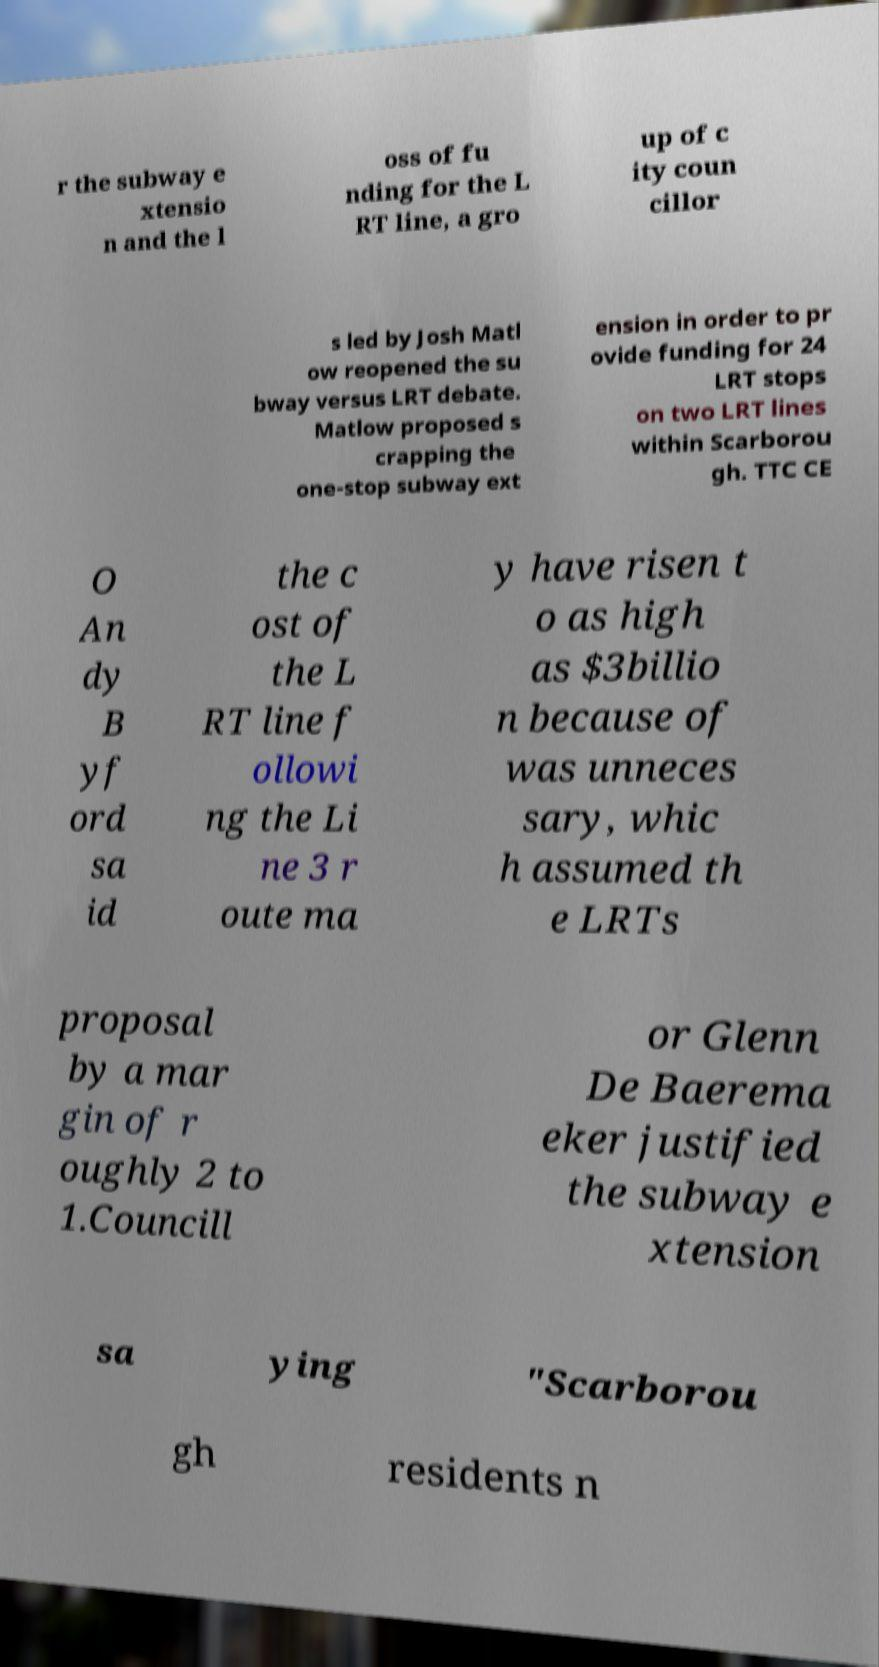Please identify and transcribe the text found in this image. r the subway e xtensio n and the l oss of fu nding for the L RT line, a gro up of c ity coun cillor s led by Josh Matl ow reopened the su bway versus LRT debate. Matlow proposed s crapping the one-stop subway ext ension in order to pr ovide funding for 24 LRT stops on two LRT lines within Scarborou gh. TTC CE O An dy B yf ord sa id the c ost of the L RT line f ollowi ng the Li ne 3 r oute ma y have risen t o as high as $3billio n because of was unneces sary, whic h assumed th e LRTs proposal by a mar gin of r oughly 2 to 1.Councill or Glenn De Baerema eker justified the subway e xtension sa ying "Scarborou gh residents n 